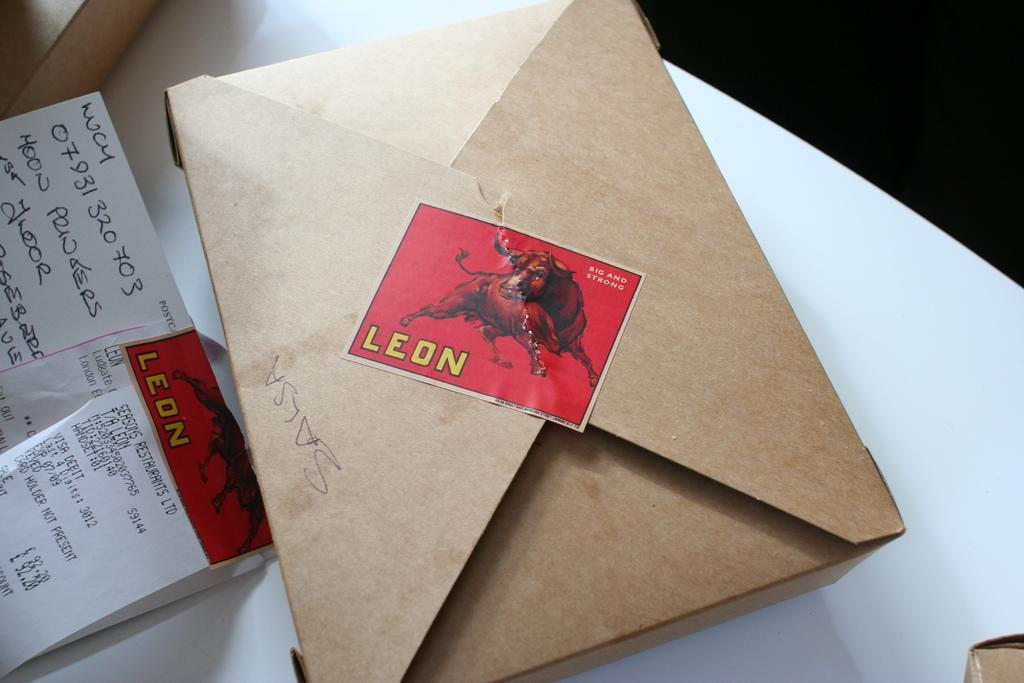<image>
Share a concise interpretation of the image provided. A cardboard box is on a table sealed with a sticker that says Leon. 